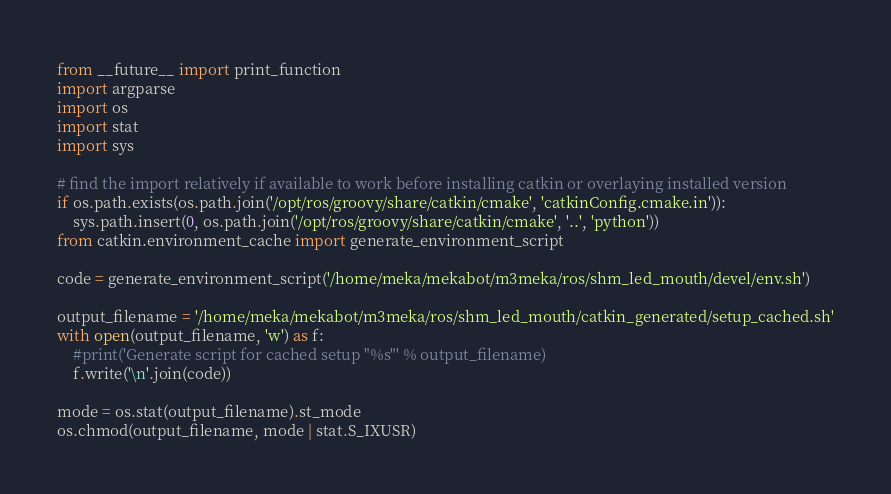<code> <loc_0><loc_0><loc_500><loc_500><_Python_>from __future__ import print_function
import argparse
import os
import stat
import sys

# find the import relatively if available to work before installing catkin or overlaying installed version
if os.path.exists(os.path.join('/opt/ros/groovy/share/catkin/cmake', 'catkinConfig.cmake.in')):
    sys.path.insert(0, os.path.join('/opt/ros/groovy/share/catkin/cmake', '..', 'python'))
from catkin.environment_cache import generate_environment_script

code = generate_environment_script('/home/meka/mekabot/m3meka/ros/shm_led_mouth/devel/env.sh')

output_filename = '/home/meka/mekabot/m3meka/ros/shm_led_mouth/catkin_generated/setup_cached.sh'
with open(output_filename, 'w') as f:
    #print('Generate script for cached setup "%s"' % output_filename)
    f.write('\n'.join(code))

mode = os.stat(output_filename).st_mode
os.chmod(output_filename, mode | stat.S_IXUSR)
</code> 